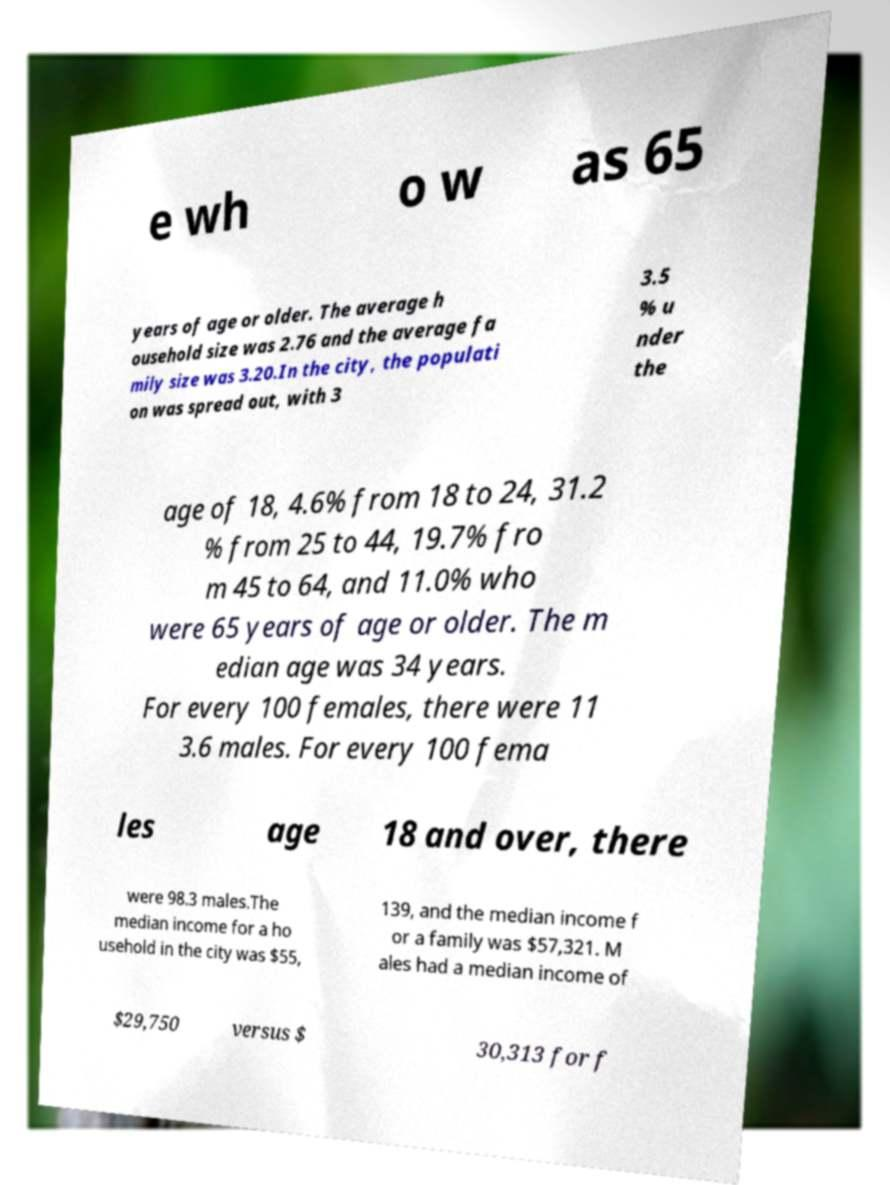Could you assist in decoding the text presented in this image and type it out clearly? e wh o w as 65 years of age or older. The average h ousehold size was 2.76 and the average fa mily size was 3.20.In the city, the populati on was spread out, with 3 3.5 % u nder the age of 18, 4.6% from 18 to 24, 31.2 % from 25 to 44, 19.7% fro m 45 to 64, and 11.0% who were 65 years of age or older. The m edian age was 34 years. For every 100 females, there were 11 3.6 males. For every 100 fema les age 18 and over, there were 98.3 males.The median income for a ho usehold in the city was $55, 139, and the median income f or a family was $57,321. M ales had a median income of $29,750 versus $ 30,313 for f 